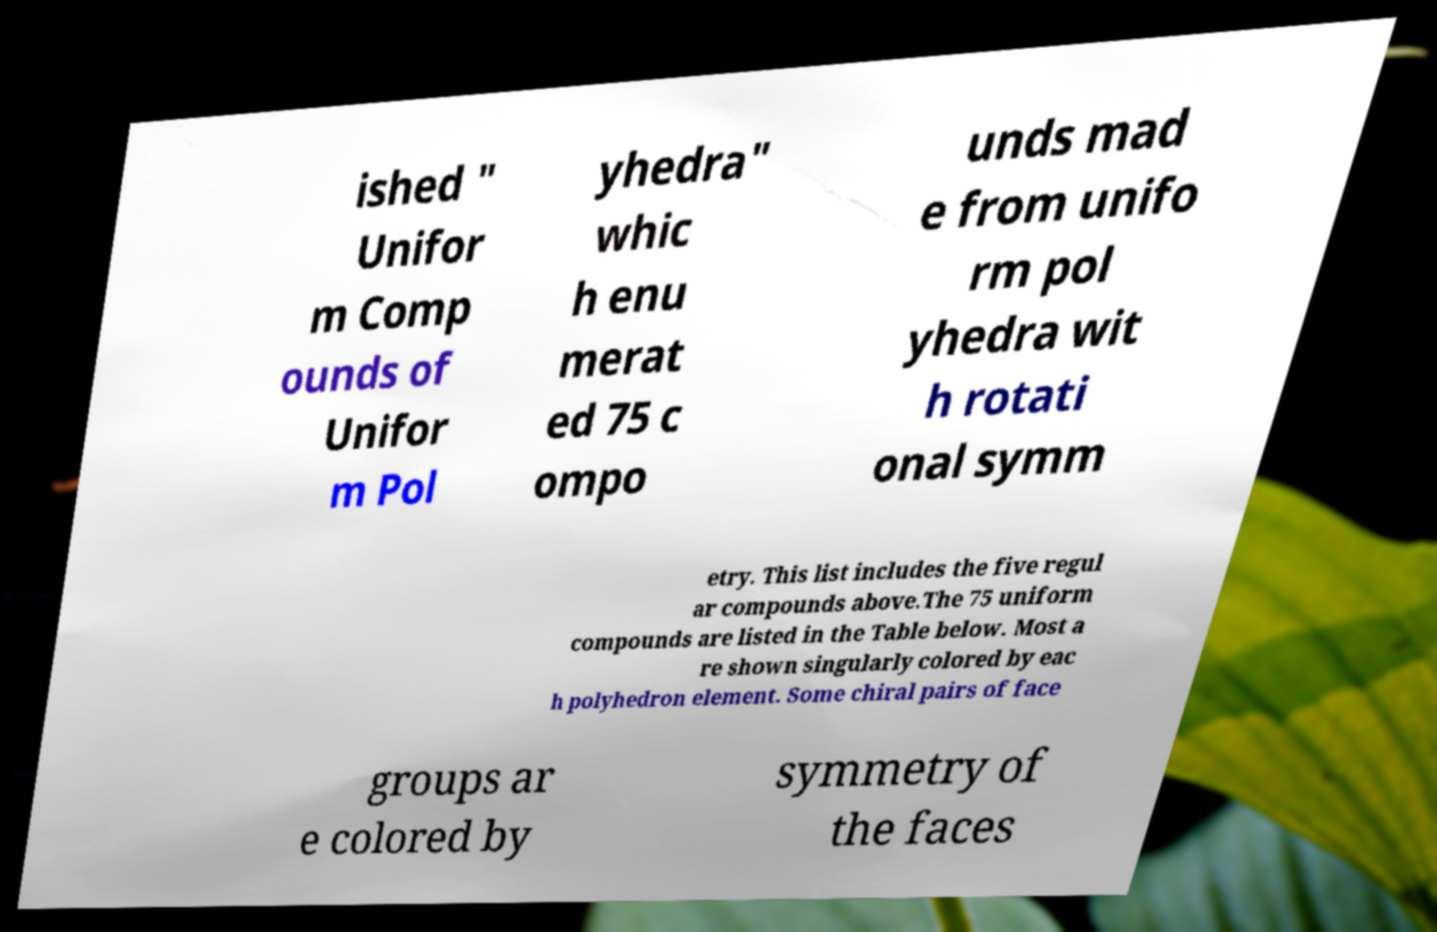For documentation purposes, I need the text within this image transcribed. Could you provide that? ished " Unifor m Comp ounds of Unifor m Pol yhedra" whic h enu merat ed 75 c ompo unds mad e from unifo rm pol yhedra wit h rotati onal symm etry. This list includes the five regul ar compounds above.The 75 uniform compounds are listed in the Table below. Most a re shown singularly colored by eac h polyhedron element. Some chiral pairs of face groups ar e colored by symmetry of the faces 